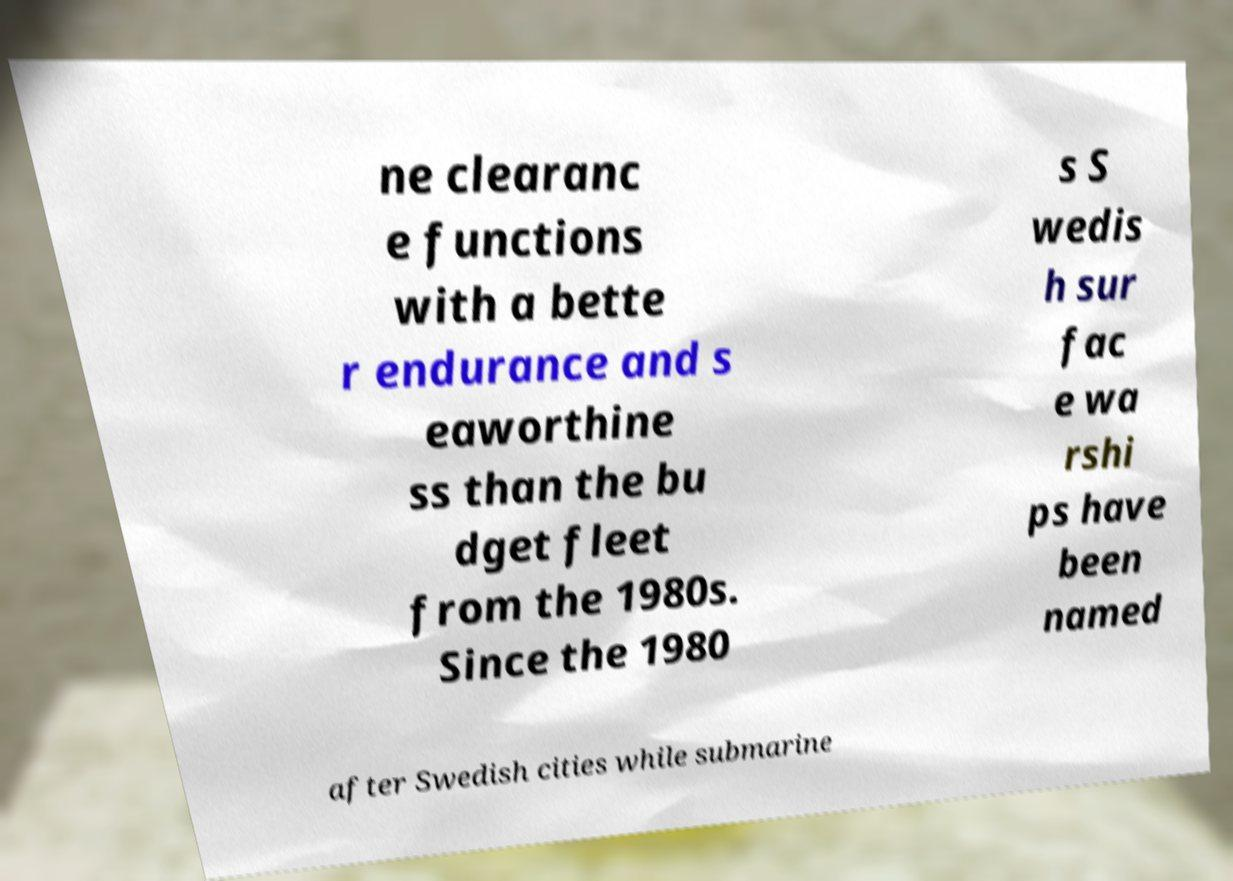For documentation purposes, I need the text within this image transcribed. Could you provide that? ne clearanc e functions with a bette r endurance and s eaworthine ss than the bu dget fleet from the 1980s. Since the 1980 s S wedis h sur fac e wa rshi ps have been named after Swedish cities while submarine 